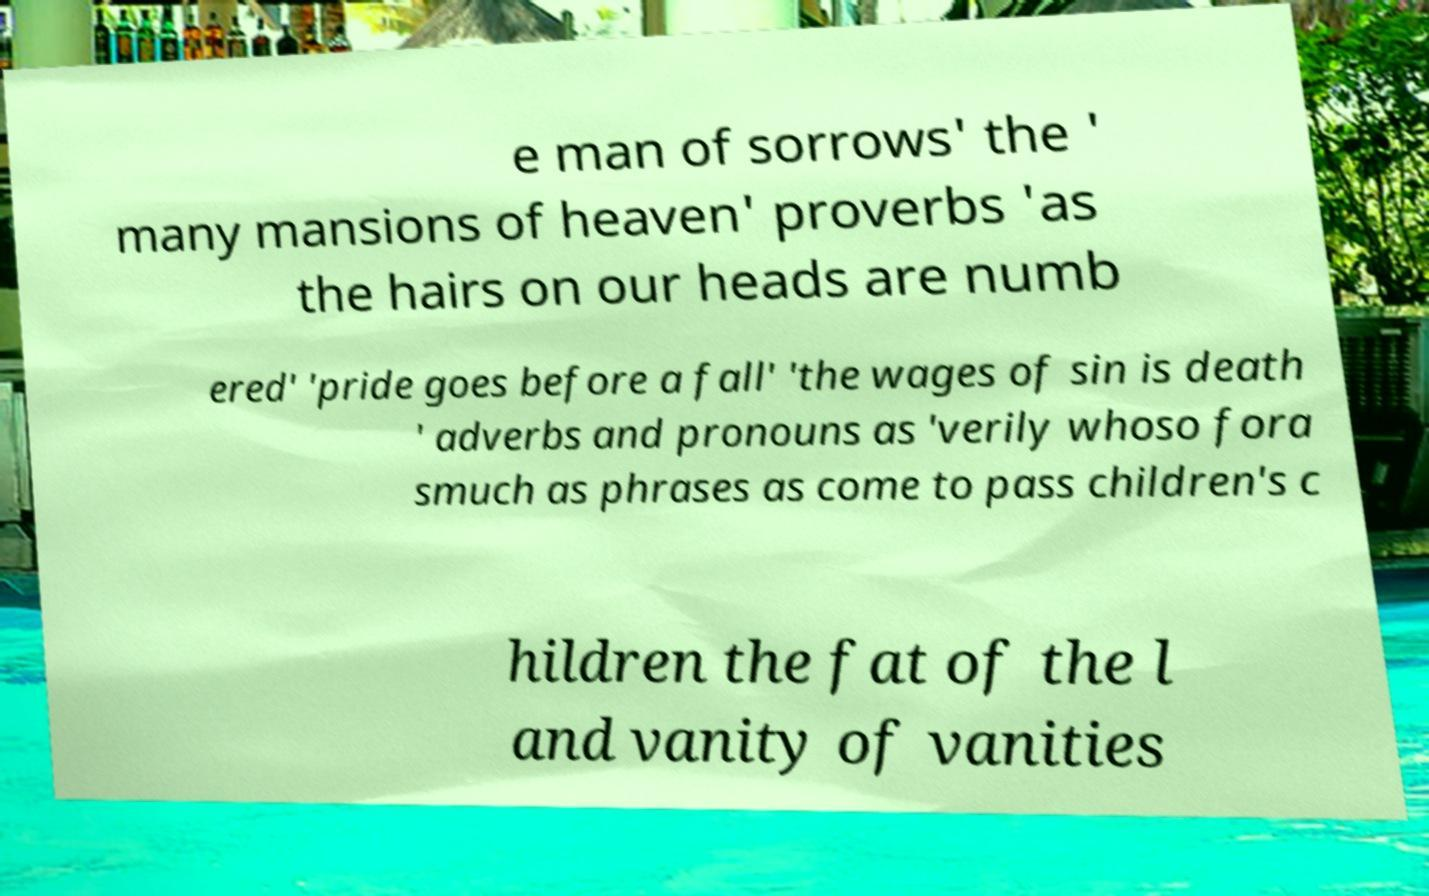Could you extract and type out the text from this image? e man of sorrows' the ' many mansions of heaven' proverbs 'as the hairs on our heads are numb ered' 'pride goes before a fall' 'the wages of sin is death ' adverbs and pronouns as 'verily whoso fora smuch as phrases as come to pass children's c hildren the fat of the l and vanity of vanities 